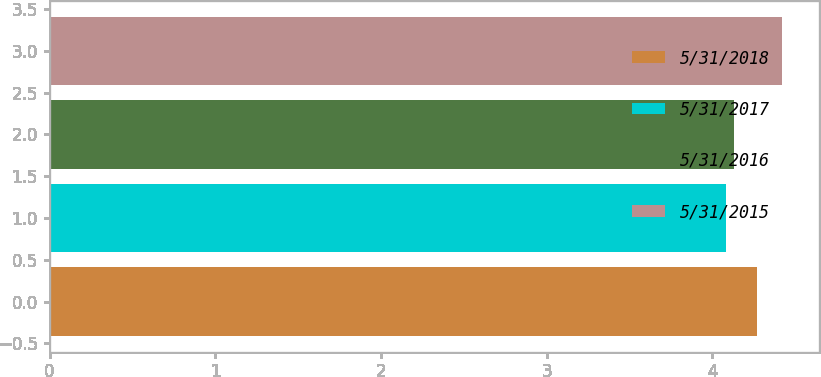<chart> <loc_0><loc_0><loc_500><loc_500><bar_chart><fcel>5/31/2018<fcel>5/31/2017<fcel>5/31/2016<fcel>5/31/2015<nl><fcel>4.27<fcel>4.08<fcel>4.13<fcel>4.42<nl></chart> 